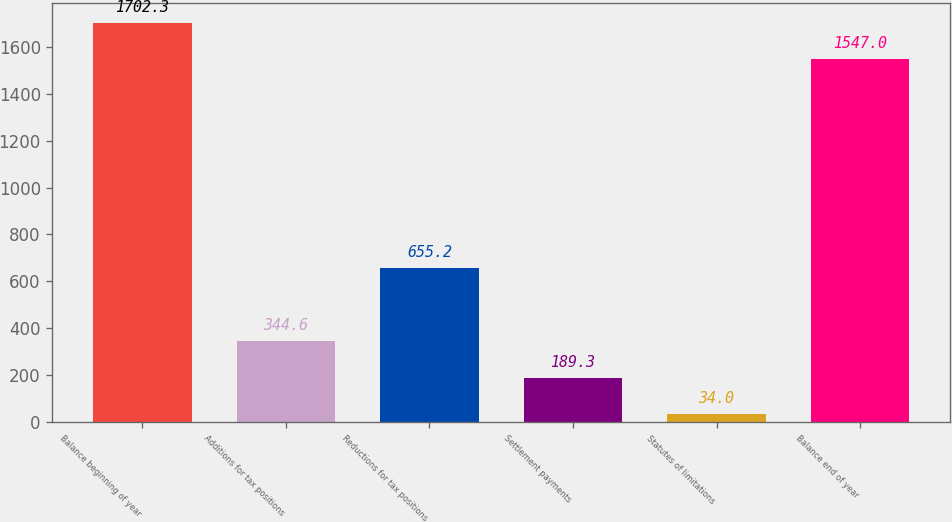Convert chart. <chart><loc_0><loc_0><loc_500><loc_500><bar_chart><fcel>Balance beginning of year<fcel>Additions for tax positions<fcel>Reductions for tax positions<fcel>Settlement payments<fcel>Statutes of limitations<fcel>Balance end of year<nl><fcel>1702.3<fcel>344.6<fcel>655.2<fcel>189.3<fcel>34<fcel>1547<nl></chart> 